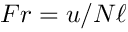<formula> <loc_0><loc_0><loc_500><loc_500>F r = u / N \ell</formula> 